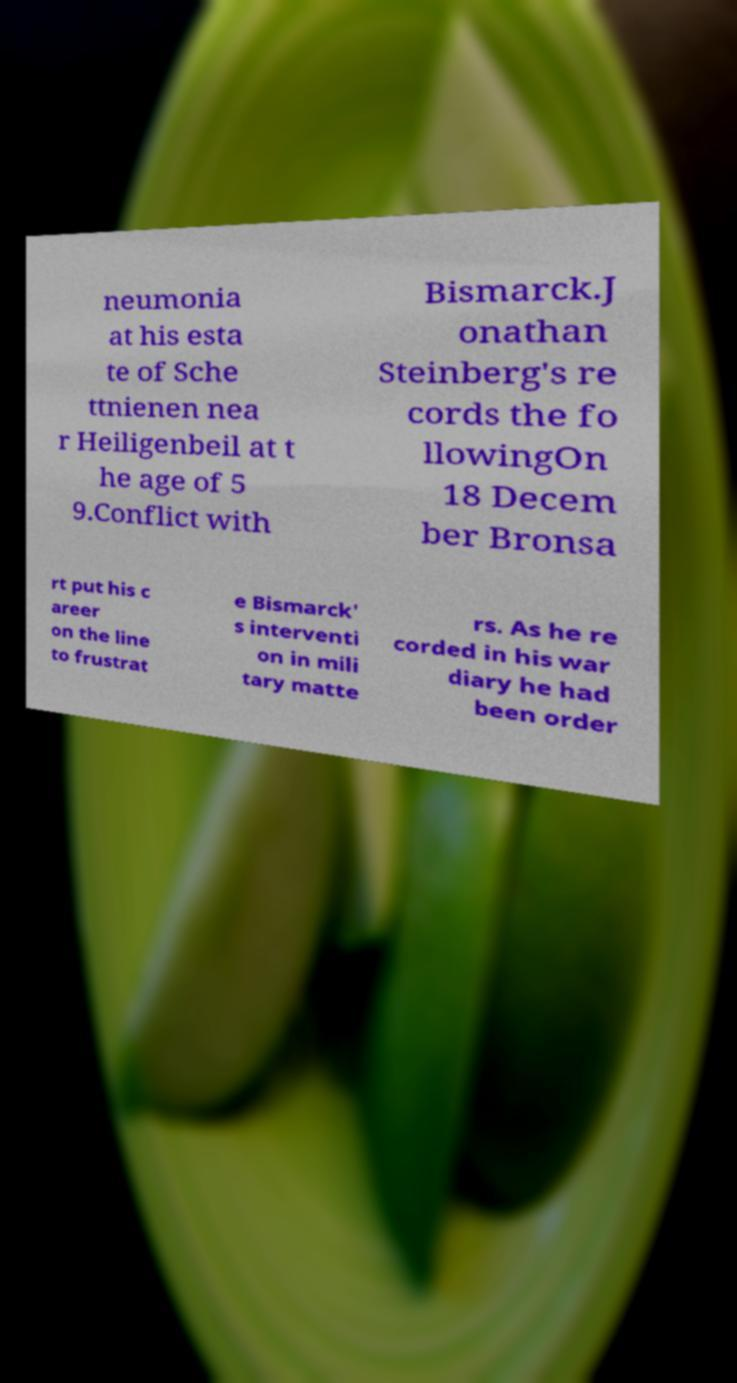There's text embedded in this image that I need extracted. Can you transcribe it verbatim? neumonia at his esta te of Sche ttnienen nea r Heiligenbeil at t he age of 5 9.Conflict with Bismarck.J onathan Steinberg's re cords the fo llowingOn 18 Decem ber Bronsa rt put his c areer on the line to frustrat e Bismarck' s interventi on in mili tary matte rs. As he re corded in his war diary he had been order 